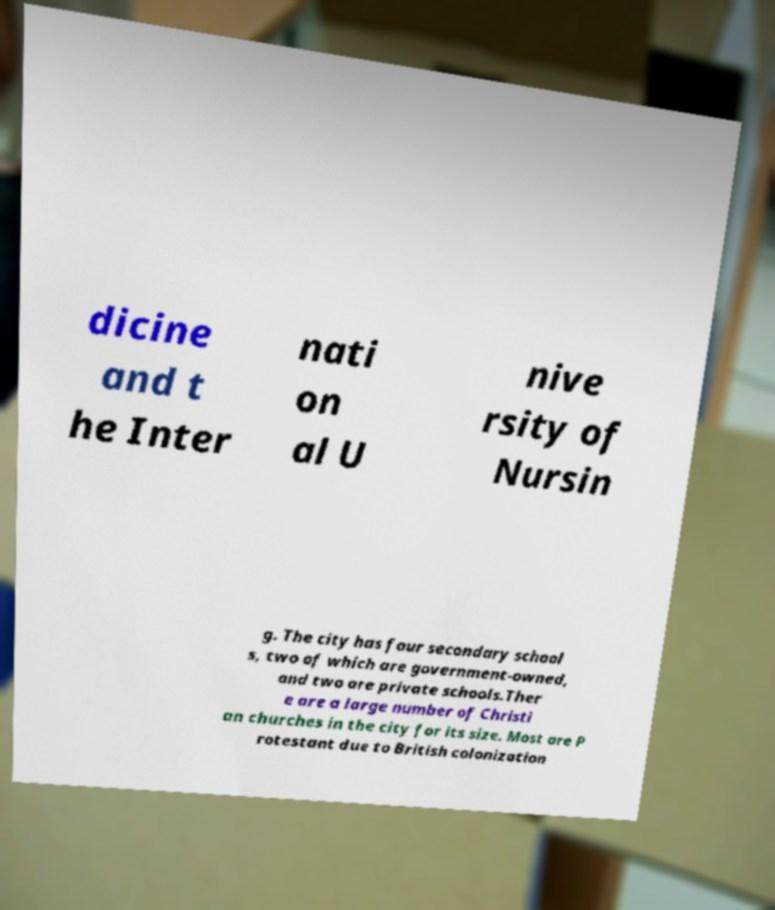For documentation purposes, I need the text within this image transcribed. Could you provide that? dicine and t he Inter nati on al U nive rsity of Nursin g. The city has four secondary school s, two of which are government-owned, and two are private schools.Ther e are a large number of Christi an churches in the city for its size. Most are P rotestant due to British colonization 